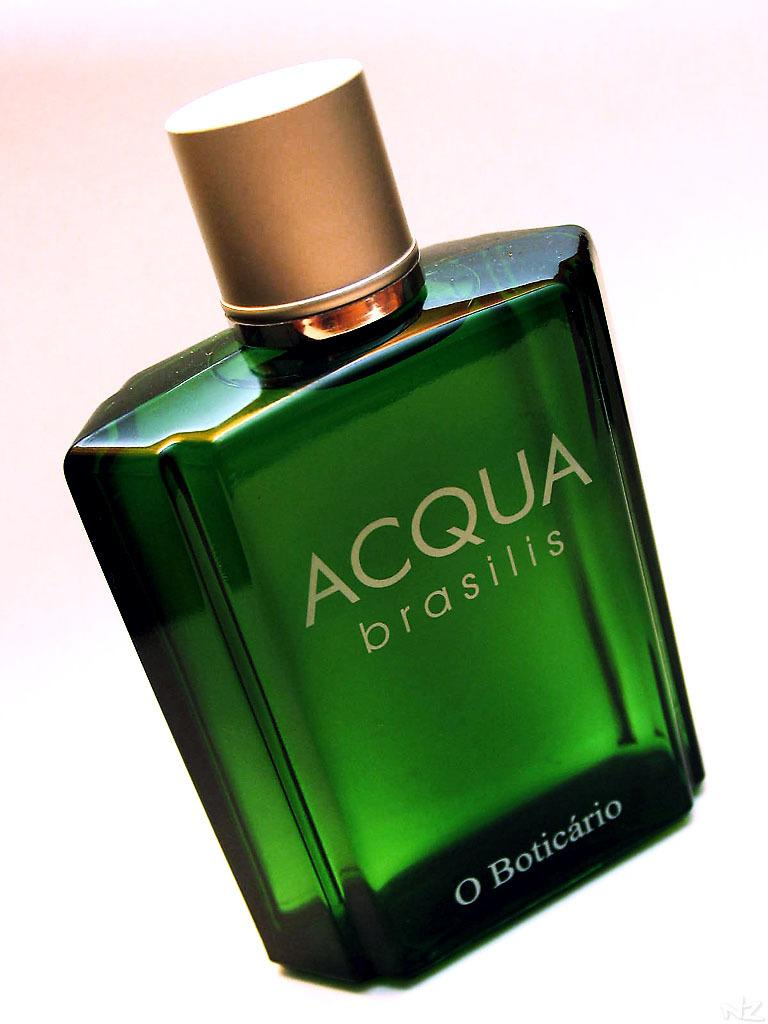Provide a one-sentence caption for the provided image. A close up shows a green bottle of Acqua brasilis by O Boticario. 